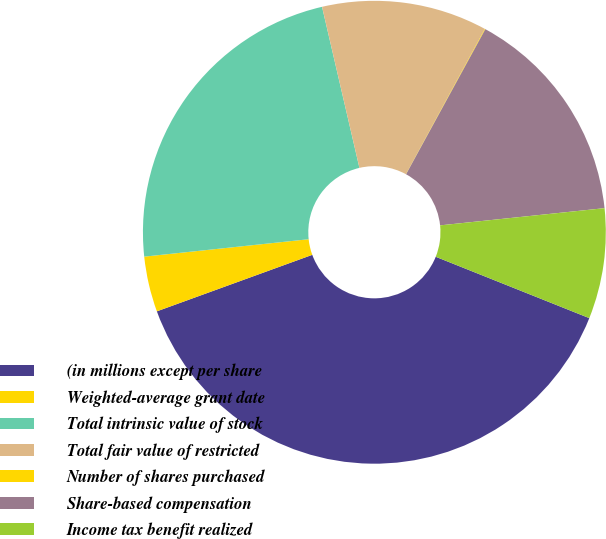Convert chart. <chart><loc_0><loc_0><loc_500><loc_500><pie_chart><fcel>(in millions except per share<fcel>Weighted-average grant date<fcel>Total intrinsic value of stock<fcel>Total fair value of restricted<fcel>Number of shares purchased<fcel>Share-based compensation<fcel>Income tax benefit realized<nl><fcel>38.4%<fcel>3.87%<fcel>23.05%<fcel>11.55%<fcel>0.04%<fcel>15.38%<fcel>7.71%<nl></chart> 